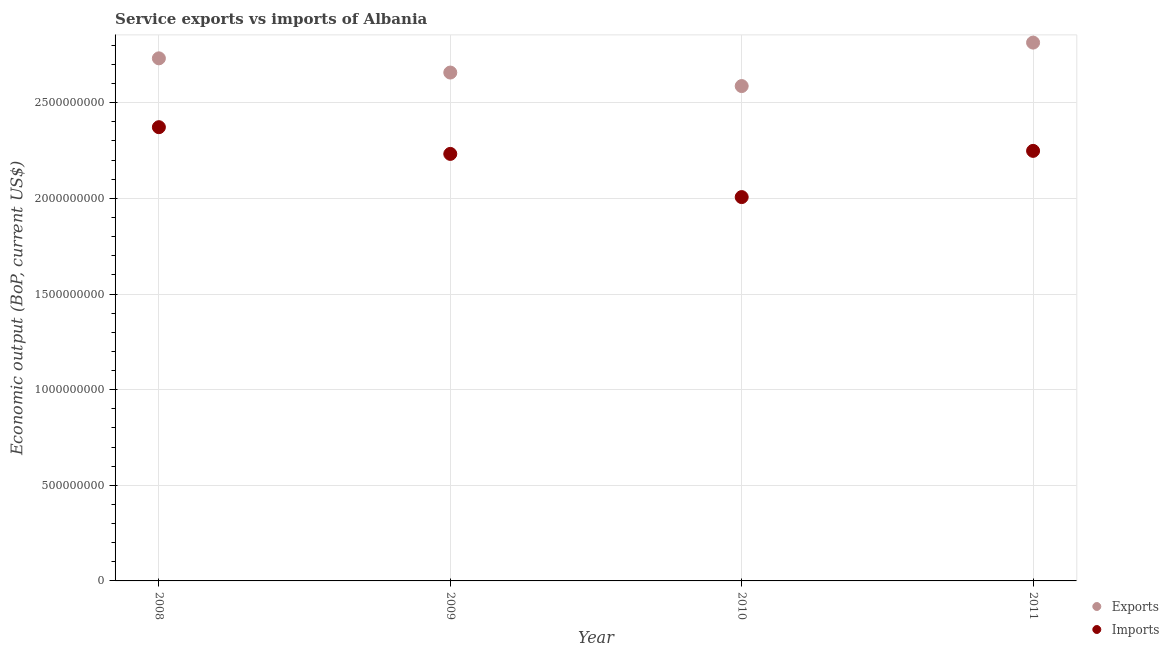How many different coloured dotlines are there?
Give a very brief answer. 2. What is the amount of service imports in 2010?
Your response must be concise. 2.01e+09. Across all years, what is the maximum amount of service imports?
Keep it short and to the point. 2.37e+09. Across all years, what is the minimum amount of service exports?
Keep it short and to the point. 2.59e+09. In which year was the amount of service imports maximum?
Provide a short and direct response. 2008. In which year was the amount of service imports minimum?
Your answer should be very brief. 2010. What is the total amount of service exports in the graph?
Ensure brevity in your answer.  1.08e+1. What is the difference between the amount of service exports in 2009 and that in 2010?
Provide a succinct answer. 7.07e+07. What is the difference between the amount of service imports in 2011 and the amount of service exports in 2010?
Offer a terse response. -3.39e+08. What is the average amount of service exports per year?
Offer a terse response. 2.70e+09. In the year 2010, what is the difference between the amount of service exports and amount of service imports?
Provide a succinct answer. 5.80e+08. In how many years, is the amount of service exports greater than 1600000000 US$?
Keep it short and to the point. 4. What is the ratio of the amount of service exports in 2008 to that in 2011?
Offer a terse response. 0.97. Is the amount of service imports in 2008 less than that in 2009?
Provide a succinct answer. No. What is the difference between the highest and the second highest amount of service imports?
Make the answer very short. 1.24e+08. What is the difference between the highest and the lowest amount of service exports?
Provide a short and direct response. 2.27e+08. In how many years, is the amount of service exports greater than the average amount of service exports taken over all years?
Give a very brief answer. 2. Is the sum of the amount of service imports in 2008 and 2009 greater than the maximum amount of service exports across all years?
Your answer should be compact. Yes. Does the amount of service imports monotonically increase over the years?
Give a very brief answer. No. Is the amount of service exports strictly greater than the amount of service imports over the years?
Provide a short and direct response. Yes. How many dotlines are there?
Your answer should be compact. 2. How many years are there in the graph?
Your answer should be very brief. 4. Where does the legend appear in the graph?
Offer a very short reply. Bottom right. How many legend labels are there?
Make the answer very short. 2. How are the legend labels stacked?
Offer a terse response. Vertical. What is the title of the graph?
Provide a succinct answer. Service exports vs imports of Albania. What is the label or title of the X-axis?
Provide a short and direct response. Year. What is the label or title of the Y-axis?
Offer a very short reply. Economic output (BoP, current US$). What is the Economic output (BoP, current US$) of Exports in 2008?
Offer a terse response. 2.73e+09. What is the Economic output (BoP, current US$) in Imports in 2008?
Ensure brevity in your answer.  2.37e+09. What is the Economic output (BoP, current US$) in Exports in 2009?
Offer a very short reply. 2.66e+09. What is the Economic output (BoP, current US$) in Imports in 2009?
Give a very brief answer. 2.23e+09. What is the Economic output (BoP, current US$) in Exports in 2010?
Provide a succinct answer. 2.59e+09. What is the Economic output (BoP, current US$) in Imports in 2010?
Make the answer very short. 2.01e+09. What is the Economic output (BoP, current US$) of Exports in 2011?
Make the answer very short. 2.81e+09. What is the Economic output (BoP, current US$) of Imports in 2011?
Your answer should be compact. 2.25e+09. Across all years, what is the maximum Economic output (BoP, current US$) of Exports?
Your answer should be very brief. 2.81e+09. Across all years, what is the maximum Economic output (BoP, current US$) in Imports?
Offer a terse response. 2.37e+09. Across all years, what is the minimum Economic output (BoP, current US$) of Exports?
Make the answer very short. 2.59e+09. Across all years, what is the minimum Economic output (BoP, current US$) of Imports?
Offer a very short reply. 2.01e+09. What is the total Economic output (BoP, current US$) in Exports in the graph?
Your answer should be very brief. 1.08e+1. What is the total Economic output (BoP, current US$) in Imports in the graph?
Your response must be concise. 8.86e+09. What is the difference between the Economic output (BoP, current US$) of Exports in 2008 and that in 2009?
Make the answer very short. 7.43e+07. What is the difference between the Economic output (BoP, current US$) of Imports in 2008 and that in 2009?
Provide a short and direct response. 1.40e+08. What is the difference between the Economic output (BoP, current US$) in Exports in 2008 and that in 2010?
Your response must be concise. 1.45e+08. What is the difference between the Economic output (BoP, current US$) of Imports in 2008 and that in 2010?
Offer a terse response. 3.65e+08. What is the difference between the Economic output (BoP, current US$) of Exports in 2008 and that in 2011?
Make the answer very short. -8.23e+07. What is the difference between the Economic output (BoP, current US$) in Imports in 2008 and that in 2011?
Provide a short and direct response. 1.24e+08. What is the difference between the Economic output (BoP, current US$) of Exports in 2009 and that in 2010?
Ensure brevity in your answer.  7.07e+07. What is the difference between the Economic output (BoP, current US$) in Imports in 2009 and that in 2010?
Provide a succinct answer. 2.26e+08. What is the difference between the Economic output (BoP, current US$) in Exports in 2009 and that in 2011?
Ensure brevity in your answer.  -1.57e+08. What is the difference between the Economic output (BoP, current US$) in Imports in 2009 and that in 2011?
Your answer should be very brief. -1.58e+07. What is the difference between the Economic output (BoP, current US$) in Exports in 2010 and that in 2011?
Your answer should be compact. -2.27e+08. What is the difference between the Economic output (BoP, current US$) in Imports in 2010 and that in 2011?
Your response must be concise. -2.42e+08. What is the difference between the Economic output (BoP, current US$) in Exports in 2008 and the Economic output (BoP, current US$) in Imports in 2009?
Your answer should be very brief. 5.00e+08. What is the difference between the Economic output (BoP, current US$) of Exports in 2008 and the Economic output (BoP, current US$) of Imports in 2010?
Make the answer very short. 7.25e+08. What is the difference between the Economic output (BoP, current US$) in Exports in 2008 and the Economic output (BoP, current US$) in Imports in 2011?
Your response must be concise. 4.84e+08. What is the difference between the Economic output (BoP, current US$) in Exports in 2009 and the Economic output (BoP, current US$) in Imports in 2010?
Provide a succinct answer. 6.51e+08. What is the difference between the Economic output (BoP, current US$) of Exports in 2009 and the Economic output (BoP, current US$) of Imports in 2011?
Ensure brevity in your answer.  4.09e+08. What is the difference between the Economic output (BoP, current US$) in Exports in 2010 and the Economic output (BoP, current US$) in Imports in 2011?
Your answer should be compact. 3.39e+08. What is the average Economic output (BoP, current US$) of Exports per year?
Keep it short and to the point. 2.70e+09. What is the average Economic output (BoP, current US$) in Imports per year?
Your answer should be very brief. 2.21e+09. In the year 2008, what is the difference between the Economic output (BoP, current US$) of Exports and Economic output (BoP, current US$) of Imports?
Keep it short and to the point. 3.60e+08. In the year 2009, what is the difference between the Economic output (BoP, current US$) of Exports and Economic output (BoP, current US$) of Imports?
Offer a very short reply. 4.25e+08. In the year 2010, what is the difference between the Economic output (BoP, current US$) of Exports and Economic output (BoP, current US$) of Imports?
Make the answer very short. 5.80e+08. In the year 2011, what is the difference between the Economic output (BoP, current US$) of Exports and Economic output (BoP, current US$) of Imports?
Provide a succinct answer. 5.66e+08. What is the ratio of the Economic output (BoP, current US$) of Exports in 2008 to that in 2009?
Keep it short and to the point. 1.03. What is the ratio of the Economic output (BoP, current US$) of Imports in 2008 to that in 2009?
Offer a very short reply. 1.06. What is the ratio of the Economic output (BoP, current US$) in Exports in 2008 to that in 2010?
Make the answer very short. 1.06. What is the ratio of the Economic output (BoP, current US$) in Imports in 2008 to that in 2010?
Your response must be concise. 1.18. What is the ratio of the Economic output (BoP, current US$) of Exports in 2008 to that in 2011?
Make the answer very short. 0.97. What is the ratio of the Economic output (BoP, current US$) of Imports in 2008 to that in 2011?
Give a very brief answer. 1.06. What is the ratio of the Economic output (BoP, current US$) of Exports in 2009 to that in 2010?
Provide a short and direct response. 1.03. What is the ratio of the Economic output (BoP, current US$) in Imports in 2009 to that in 2010?
Your answer should be compact. 1.11. What is the ratio of the Economic output (BoP, current US$) in Exports in 2009 to that in 2011?
Make the answer very short. 0.94. What is the ratio of the Economic output (BoP, current US$) in Exports in 2010 to that in 2011?
Your answer should be very brief. 0.92. What is the ratio of the Economic output (BoP, current US$) in Imports in 2010 to that in 2011?
Your response must be concise. 0.89. What is the difference between the highest and the second highest Economic output (BoP, current US$) in Exports?
Keep it short and to the point. 8.23e+07. What is the difference between the highest and the second highest Economic output (BoP, current US$) in Imports?
Offer a terse response. 1.24e+08. What is the difference between the highest and the lowest Economic output (BoP, current US$) in Exports?
Your answer should be compact. 2.27e+08. What is the difference between the highest and the lowest Economic output (BoP, current US$) in Imports?
Offer a very short reply. 3.65e+08. 